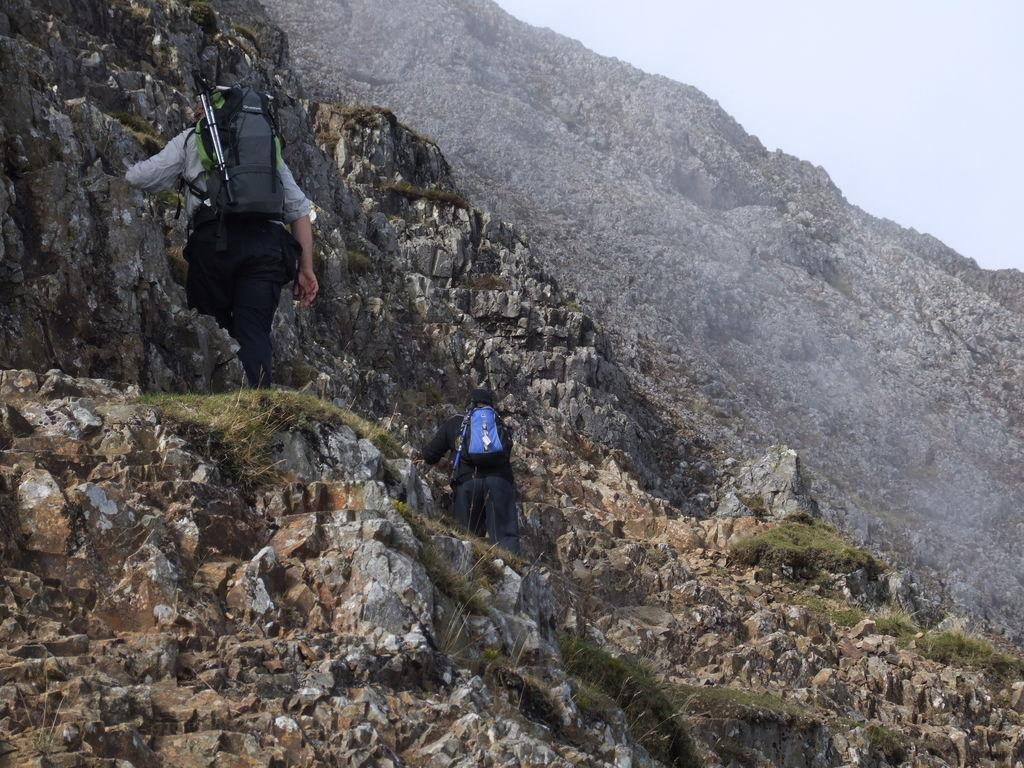What geographical feature is present in the image? There is a hill in the image. Are there any people on the hill? Yes, two persons are standing on the hill. What part of the natural environment can be seen in the image? The sky is visible in the top right corner of the image. Can you tell me how many children are playing in the sea in the image? There is no sea or children present in the image; it features a hill with two persons standing on it. What type of drink is being consumed by the persons on the hill? There is no drink visible in the image, as it only shows a hill with two persons standing on it. 